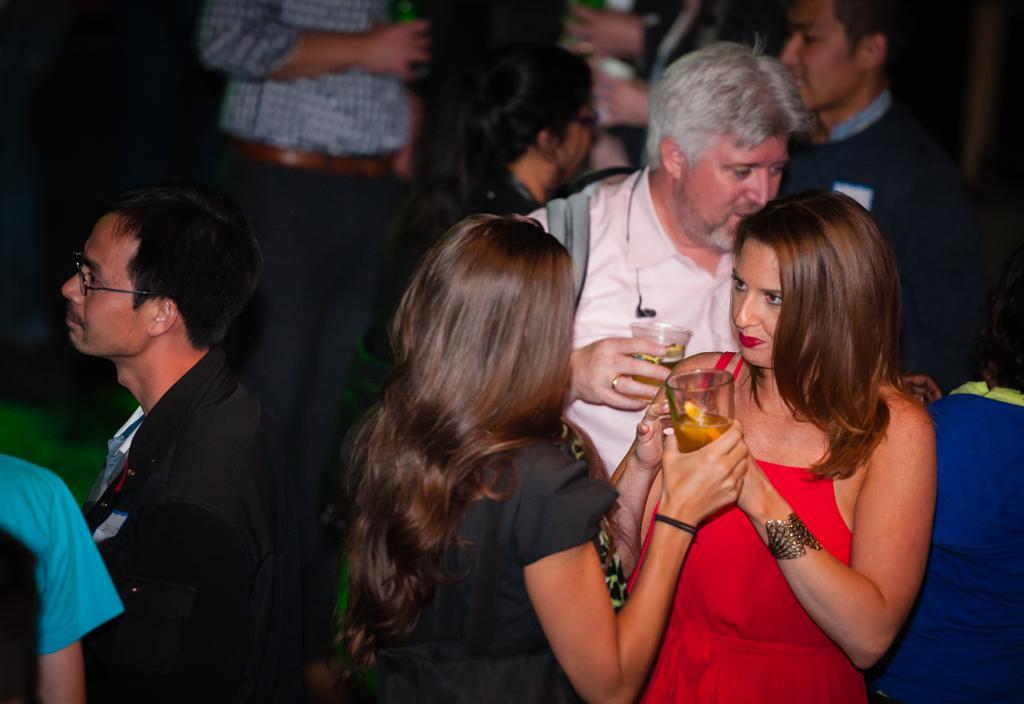Can you describe this image briefly? In this image we can see people standing on the floor and some are holding beverage glasses in their hands. 